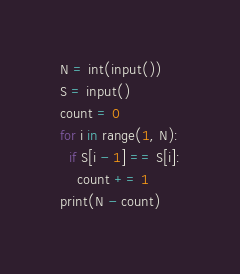Convert code to text. <code><loc_0><loc_0><loc_500><loc_500><_Python_>N = int(input())
S = input()
count = 0
for i in range(1, N):
  if S[i - 1] == S[i]:
    count += 1
print(N - count)
</code> 